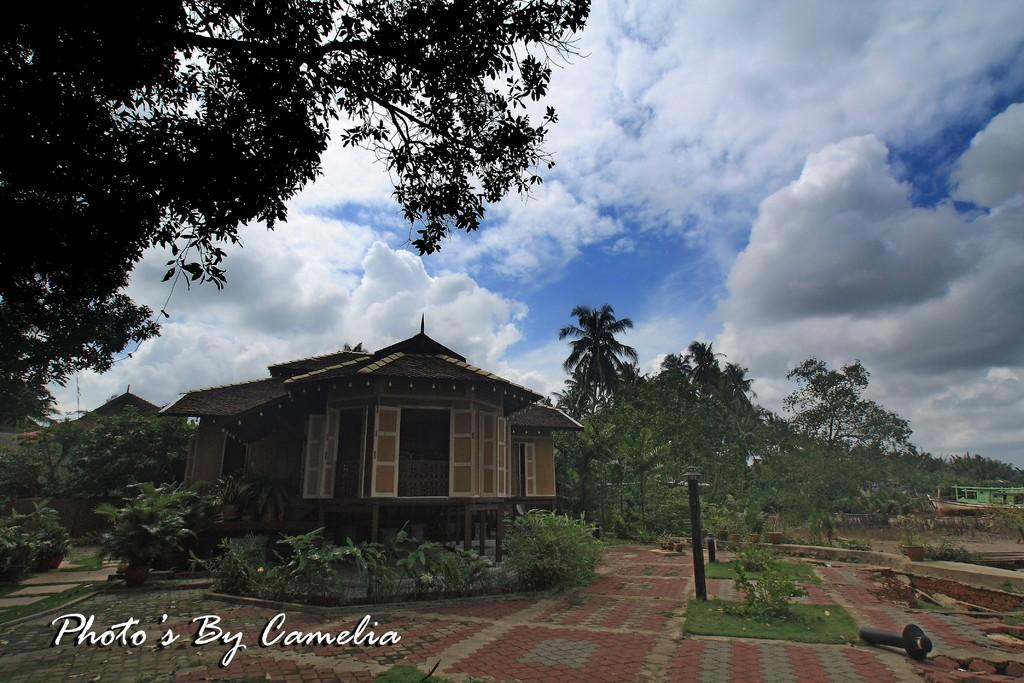What type of structures can be seen in the image? There are buildings in the image. What natural elements are present in the image? There are trees and plants in the image. Can you describe the object that resembles a rod? Yes, there is a rod in the image. What is visible in the background of the image? The sky is visible in the background of the image. What can be seen in the sky? There are clouds in the sky. What type of hat is the station wearing in the image? There is no station or hat present in the image. What time of day is it in the image, considering the presence of morning light? The provided facts do not mention anything about morning light or the time of day, so it cannot be determined from the image. 